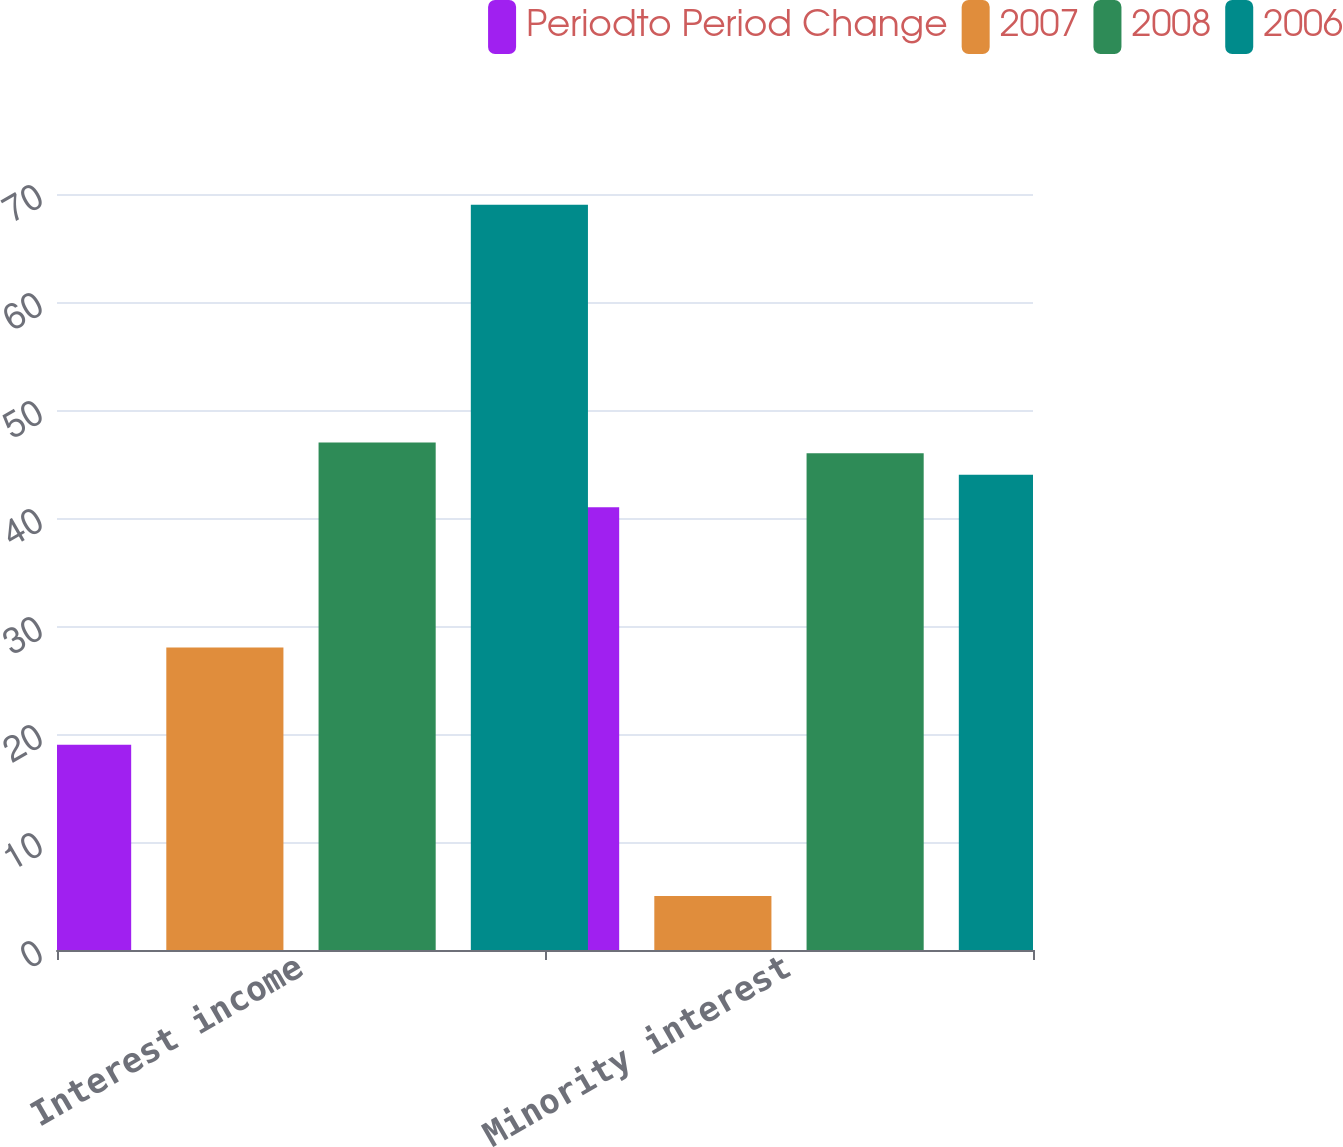Convert chart. <chart><loc_0><loc_0><loc_500><loc_500><stacked_bar_chart><ecel><fcel>Interest income<fcel>Minority interest<nl><fcel>Periodto Period Change<fcel>19<fcel>41<nl><fcel>2007<fcel>28<fcel>5<nl><fcel>2008<fcel>47<fcel>46<nl><fcel>2006<fcel>69<fcel>44<nl></chart> 